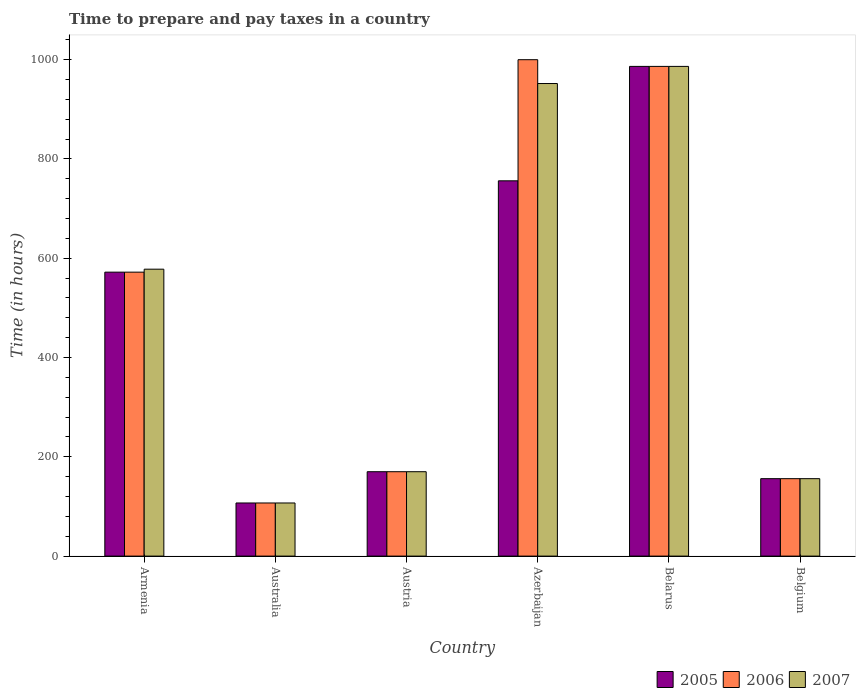How many groups of bars are there?
Give a very brief answer. 6. Are the number of bars per tick equal to the number of legend labels?
Provide a succinct answer. Yes. How many bars are there on the 4th tick from the left?
Offer a very short reply. 3. What is the label of the 2nd group of bars from the left?
Your response must be concise. Australia. In how many cases, is the number of bars for a given country not equal to the number of legend labels?
Keep it short and to the point. 0. What is the number of hours required to prepare and pay taxes in 2005 in Belarus?
Offer a very short reply. 986.5. Across all countries, what is the maximum number of hours required to prepare and pay taxes in 2006?
Your answer should be very brief. 1000. Across all countries, what is the minimum number of hours required to prepare and pay taxes in 2007?
Offer a terse response. 107. In which country was the number of hours required to prepare and pay taxes in 2005 maximum?
Your answer should be compact. Belarus. In which country was the number of hours required to prepare and pay taxes in 2006 minimum?
Offer a very short reply. Australia. What is the total number of hours required to prepare and pay taxes in 2007 in the graph?
Your answer should be compact. 2949.5. What is the difference between the number of hours required to prepare and pay taxes in 2007 in Austria and that in Azerbaijan?
Keep it short and to the point. -782. What is the difference between the number of hours required to prepare and pay taxes in 2005 in Azerbaijan and the number of hours required to prepare and pay taxes in 2006 in Austria?
Offer a very short reply. 586. What is the average number of hours required to prepare and pay taxes in 2005 per country?
Offer a very short reply. 457.92. In how many countries, is the number of hours required to prepare and pay taxes in 2006 greater than 520 hours?
Make the answer very short. 3. What is the ratio of the number of hours required to prepare and pay taxes in 2005 in Austria to that in Belarus?
Keep it short and to the point. 0.17. What is the difference between the highest and the second highest number of hours required to prepare and pay taxes in 2007?
Offer a terse response. -34.5. What is the difference between the highest and the lowest number of hours required to prepare and pay taxes in 2005?
Provide a succinct answer. 879.5. Is it the case that in every country, the sum of the number of hours required to prepare and pay taxes in 2007 and number of hours required to prepare and pay taxes in 2006 is greater than the number of hours required to prepare and pay taxes in 2005?
Ensure brevity in your answer.  Yes. How many bars are there?
Give a very brief answer. 18. How many countries are there in the graph?
Offer a terse response. 6. What is the difference between two consecutive major ticks on the Y-axis?
Offer a very short reply. 200. Where does the legend appear in the graph?
Offer a very short reply. Bottom right. How many legend labels are there?
Offer a terse response. 3. What is the title of the graph?
Your response must be concise. Time to prepare and pay taxes in a country. What is the label or title of the X-axis?
Offer a very short reply. Country. What is the label or title of the Y-axis?
Make the answer very short. Time (in hours). What is the Time (in hours) in 2005 in Armenia?
Offer a very short reply. 572. What is the Time (in hours) in 2006 in Armenia?
Keep it short and to the point. 572. What is the Time (in hours) of 2007 in Armenia?
Offer a terse response. 578. What is the Time (in hours) of 2005 in Australia?
Offer a terse response. 107. What is the Time (in hours) of 2006 in Australia?
Give a very brief answer. 107. What is the Time (in hours) in 2007 in Australia?
Keep it short and to the point. 107. What is the Time (in hours) of 2005 in Austria?
Ensure brevity in your answer.  170. What is the Time (in hours) in 2006 in Austria?
Offer a very short reply. 170. What is the Time (in hours) in 2007 in Austria?
Keep it short and to the point. 170. What is the Time (in hours) of 2005 in Azerbaijan?
Provide a short and direct response. 756. What is the Time (in hours) of 2007 in Azerbaijan?
Provide a short and direct response. 952. What is the Time (in hours) of 2005 in Belarus?
Make the answer very short. 986.5. What is the Time (in hours) of 2006 in Belarus?
Provide a succinct answer. 986.5. What is the Time (in hours) of 2007 in Belarus?
Keep it short and to the point. 986.5. What is the Time (in hours) of 2005 in Belgium?
Make the answer very short. 156. What is the Time (in hours) of 2006 in Belgium?
Ensure brevity in your answer.  156. What is the Time (in hours) in 2007 in Belgium?
Give a very brief answer. 156. Across all countries, what is the maximum Time (in hours) of 2005?
Provide a short and direct response. 986.5. Across all countries, what is the maximum Time (in hours) of 2007?
Your answer should be very brief. 986.5. Across all countries, what is the minimum Time (in hours) in 2005?
Your answer should be compact. 107. Across all countries, what is the minimum Time (in hours) in 2006?
Ensure brevity in your answer.  107. Across all countries, what is the minimum Time (in hours) of 2007?
Your response must be concise. 107. What is the total Time (in hours) in 2005 in the graph?
Make the answer very short. 2747.5. What is the total Time (in hours) of 2006 in the graph?
Your response must be concise. 2991.5. What is the total Time (in hours) in 2007 in the graph?
Your answer should be very brief. 2949.5. What is the difference between the Time (in hours) of 2005 in Armenia and that in Australia?
Your answer should be very brief. 465. What is the difference between the Time (in hours) of 2006 in Armenia and that in Australia?
Your response must be concise. 465. What is the difference between the Time (in hours) in 2007 in Armenia and that in Australia?
Offer a terse response. 471. What is the difference between the Time (in hours) of 2005 in Armenia and that in Austria?
Offer a terse response. 402. What is the difference between the Time (in hours) in 2006 in Armenia and that in Austria?
Make the answer very short. 402. What is the difference between the Time (in hours) in 2007 in Armenia and that in Austria?
Your answer should be very brief. 408. What is the difference between the Time (in hours) in 2005 in Armenia and that in Azerbaijan?
Your response must be concise. -184. What is the difference between the Time (in hours) of 2006 in Armenia and that in Azerbaijan?
Provide a succinct answer. -428. What is the difference between the Time (in hours) of 2007 in Armenia and that in Azerbaijan?
Give a very brief answer. -374. What is the difference between the Time (in hours) in 2005 in Armenia and that in Belarus?
Ensure brevity in your answer.  -414.5. What is the difference between the Time (in hours) in 2006 in Armenia and that in Belarus?
Your answer should be compact. -414.5. What is the difference between the Time (in hours) in 2007 in Armenia and that in Belarus?
Offer a very short reply. -408.5. What is the difference between the Time (in hours) in 2005 in Armenia and that in Belgium?
Keep it short and to the point. 416. What is the difference between the Time (in hours) of 2006 in Armenia and that in Belgium?
Offer a terse response. 416. What is the difference between the Time (in hours) in 2007 in Armenia and that in Belgium?
Offer a very short reply. 422. What is the difference between the Time (in hours) in 2005 in Australia and that in Austria?
Provide a succinct answer. -63. What is the difference between the Time (in hours) in 2006 in Australia and that in Austria?
Ensure brevity in your answer.  -63. What is the difference between the Time (in hours) in 2007 in Australia and that in Austria?
Make the answer very short. -63. What is the difference between the Time (in hours) of 2005 in Australia and that in Azerbaijan?
Provide a short and direct response. -649. What is the difference between the Time (in hours) of 2006 in Australia and that in Azerbaijan?
Offer a very short reply. -893. What is the difference between the Time (in hours) in 2007 in Australia and that in Azerbaijan?
Offer a terse response. -845. What is the difference between the Time (in hours) in 2005 in Australia and that in Belarus?
Ensure brevity in your answer.  -879.5. What is the difference between the Time (in hours) in 2006 in Australia and that in Belarus?
Your answer should be compact. -879.5. What is the difference between the Time (in hours) of 2007 in Australia and that in Belarus?
Your response must be concise. -879.5. What is the difference between the Time (in hours) of 2005 in Australia and that in Belgium?
Provide a succinct answer. -49. What is the difference between the Time (in hours) of 2006 in Australia and that in Belgium?
Offer a very short reply. -49. What is the difference between the Time (in hours) of 2007 in Australia and that in Belgium?
Offer a very short reply. -49. What is the difference between the Time (in hours) of 2005 in Austria and that in Azerbaijan?
Your answer should be compact. -586. What is the difference between the Time (in hours) in 2006 in Austria and that in Azerbaijan?
Ensure brevity in your answer.  -830. What is the difference between the Time (in hours) of 2007 in Austria and that in Azerbaijan?
Provide a succinct answer. -782. What is the difference between the Time (in hours) of 2005 in Austria and that in Belarus?
Make the answer very short. -816.5. What is the difference between the Time (in hours) of 2006 in Austria and that in Belarus?
Offer a very short reply. -816.5. What is the difference between the Time (in hours) of 2007 in Austria and that in Belarus?
Your answer should be compact. -816.5. What is the difference between the Time (in hours) of 2005 in Austria and that in Belgium?
Ensure brevity in your answer.  14. What is the difference between the Time (in hours) in 2005 in Azerbaijan and that in Belarus?
Your answer should be very brief. -230.5. What is the difference between the Time (in hours) of 2007 in Azerbaijan and that in Belarus?
Provide a succinct answer. -34.5. What is the difference between the Time (in hours) of 2005 in Azerbaijan and that in Belgium?
Your answer should be very brief. 600. What is the difference between the Time (in hours) of 2006 in Azerbaijan and that in Belgium?
Provide a succinct answer. 844. What is the difference between the Time (in hours) in 2007 in Azerbaijan and that in Belgium?
Your answer should be compact. 796. What is the difference between the Time (in hours) in 2005 in Belarus and that in Belgium?
Give a very brief answer. 830.5. What is the difference between the Time (in hours) in 2006 in Belarus and that in Belgium?
Your response must be concise. 830.5. What is the difference between the Time (in hours) of 2007 in Belarus and that in Belgium?
Your answer should be very brief. 830.5. What is the difference between the Time (in hours) in 2005 in Armenia and the Time (in hours) in 2006 in Australia?
Your answer should be compact. 465. What is the difference between the Time (in hours) in 2005 in Armenia and the Time (in hours) in 2007 in Australia?
Offer a very short reply. 465. What is the difference between the Time (in hours) in 2006 in Armenia and the Time (in hours) in 2007 in Australia?
Make the answer very short. 465. What is the difference between the Time (in hours) in 2005 in Armenia and the Time (in hours) in 2006 in Austria?
Make the answer very short. 402. What is the difference between the Time (in hours) in 2005 in Armenia and the Time (in hours) in 2007 in Austria?
Keep it short and to the point. 402. What is the difference between the Time (in hours) in 2006 in Armenia and the Time (in hours) in 2007 in Austria?
Your response must be concise. 402. What is the difference between the Time (in hours) in 2005 in Armenia and the Time (in hours) in 2006 in Azerbaijan?
Your answer should be very brief. -428. What is the difference between the Time (in hours) in 2005 in Armenia and the Time (in hours) in 2007 in Azerbaijan?
Offer a terse response. -380. What is the difference between the Time (in hours) in 2006 in Armenia and the Time (in hours) in 2007 in Azerbaijan?
Your answer should be compact. -380. What is the difference between the Time (in hours) in 2005 in Armenia and the Time (in hours) in 2006 in Belarus?
Your response must be concise. -414.5. What is the difference between the Time (in hours) of 2005 in Armenia and the Time (in hours) of 2007 in Belarus?
Your response must be concise. -414.5. What is the difference between the Time (in hours) of 2006 in Armenia and the Time (in hours) of 2007 in Belarus?
Your response must be concise. -414.5. What is the difference between the Time (in hours) of 2005 in Armenia and the Time (in hours) of 2006 in Belgium?
Your response must be concise. 416. What is the difference between the Time (in hours) of 2005 in Armenia and the Time (in hours) of 2007 in Belgium?
Offer a terse response. 416. What is the difference between the Time (in hours) in 2006 in Armenia and the Time (in hours) in 2007 in Belgium?
Your response must be concise. 416. What is the difference between the Time (in hours) of 2005 in Australia and the Time (in hours) of 2006 in Austria?
Give a very brief answer. -63. What is the difference between the Time (in hours) in 2005 in Australia and the Time (in hours) in 2007 in Austria?
Offer a very short reply. -63. What is the difference between the Time (in hours) in 2006 in Australia and the Time (in hours) in 2007 in Austria?
Offer a terse response. -63. What is the difference between the Time (in hours) in 2005 in Australia and the Time (in hours) in 2006 in Azerbaijan?
Your response must be concise. -893. What is the difference between the Time (in hours) in 2005 in Australia and the Time (in hours) in 2007 in Azerbaijan?
Your response must be concise. -845. What is the difference between the Time (in hours) of 2006 in Australia and the Time (in hours) of 2007 in Azerbaijan?
Your response must be concise. -845. What is the difference between the Time (in hours) in 2005 in Australia and the Time (in hours) in 2006 in Belarus?
Give a very brief answer. -879.5. What is the difference between the Time (in hours) of 2005 in Australia and the Time (in hours) of 2007 in Belarus?
Your answer should be compact. -879.5. What is the difference between the Time (in hours) in 2006 in Australia and the Time (in hours) in 2007 in Belarus?
Offer a very short reply. -879.5. What is the difference between the Time (in hours) in 2005 in Australia and the Time (in hours) in 2006 in Belgium?
Keep it short and to the point. -49. What is the difference between the Time (in hours) in 2005 in Australia and the Time (in hours) in 2007 in Belgium?
Ensure brevity in your answer.  -49. What is the difference between the Time (in hours) in 2006 in Australia and the Time (in hours) in 2007 in Belgium?
Offer a very short reply. -49. What is the difference between the Time (in hours) of 2005 in Austria and the Time (in hours) of 2006 in Azerbaijan?
Provide a short and direct response. -830. What is the difference between the Time (in hours) of 2005 in Austria and the Time (in hours) of 2007 in Azerbaijan?
Keep it short and to the point. -782. What is the difference between the Time (in hours) of 2006 in Austria and the Time (in hours) of 2007 in Azerbaijan?
Your answer should be compact. -782. What is the difference between the Time (in hours) in 2005 in Austria and the Time (in hours) in 2006 in Belarus?
Offer a very short reply. -816.5. What is the difference between the Time (in hours) of 2005 in Austria and the Time (in hours) of 2007 in Belarus?
Provide a short and direct response. -816.5. What is the difference between the Time (in hours) of 2006 in Austria and the Time (in hours) of 2007 in Belarus?
Ensure brevity in your answer.  -816.5. What is the difference between the Time (in hours) in 2006 in Austria and the Time (in hours) in 2007 in Belgium?
Provide a short and direct response. 14. What is the difference between the Time (in hours) in 2005 in Azerbaijan and the Time (in hours) in 2006 in Belarus?
Make the answer very short. -230.5. What is the difference between the Time (in hours) in 2005 in Azerbaijan and the Time (in hours) in 2007 in Belarus?
Your answer should be very brief. -230.5. What is the difference between the Time (in hours) in 2006 in Azerbaijan and the Time (in hours) in 2007 in Belarus?
Keep it short and to the point. 13.5. What is the difference between the Time (in hours) in 2005 in Azerbaijan and the Time (in hours) in 2006 in Belgium?
Provide a succinct answer. 600. What is the difference between the Time (in hours) in 2005 in Azerbaijan and the Time (in hours) in 2007 in Belgium?
Provide a succinct answer. 600. What is the difference between the Time (in hours) of 2006 in Azerbaijan and the Time (in hours) of 2007 in Belgium?
Offer a very short reply. 844. What is the difference between the Time (in hours) in 2005 in Belarus and the Time (in hours) in 2006 in Belgium?
Provide a succinct answer. 830.5. What is the difference between the Time (in hours) of 2005 in Belarus and the Time (in hours) of 2007 in Belgium?
Ensure brevity in your answer.  830.5. What is the difference between the Time (in hours) in 2006 in Belarus and the Time (in hours) in 2007 in Belgium?
Your answer should be very brief. 830.5. What is the average Time (in hours) in 2005 per country?
Offer a very short reply. 457.92. What is the average Time (in hours) in 2006 per country?
Make the answer very short. 498.58. What is the average Time (in hours) in 2007 per country?
Ensure brevity in your answer.  491.58. What is the difference between the Time (in hours) of 2005 and Time (in hours) of 2006 in Armenia?
Keep it short and to the point. 0. What is the difference between the Time (in hours) in 2005 and Time (in hours) in 2007 in Australia?
Your answer should be compact. 0. What is the difference between the Time (in hours) of 2006 and Time (in hours) of 2007 in Australia?
Offer a terse response. 0. What is the difference between the Time (in hours) of 2005 and Time (in hours) of 2007 in Austria?
Provide a succinct answer. 0. What is the difference between the Time (in hours) in 2006 and Time (in hours) in 2007 in Austria?
Provide a succinct answer. 0. What is the difference between the Time (in hours) in 2005 and Time (in hours) in 2006 in Azerbaijan?
Keep it short and to the point. -244. What is the difference between the Time (in hours) in 2005 and Time (in hours) in 2007 in Azerbaijan?
Your answer should be compact. -196. What is the difference between the Time (in hours) in 2006 and Time (in hours) in 2007 in Azerbaijan?
Your answer should be compact. 48. What is the difference between the Time (in hours) in 2005 and Time (in hours) in 2006 in Belarus?
Your answer should be very brief. 0. What is the difference between the Time (in hours) of 2006 and Time (in hours) of 2007 in Belarus?
Your answer should be very brief. 0. What is the difference between the Time (in hours) of 2006 and Time (in hours) of 2007 in Belgium?
Your answer should be very brief. 0. What is the ratio of the Time (in hours) of 2005 in Armenia to that in Australia?
Ensure brevity in your answer.  5.35. What is the ratio of the Time (in hours) in 2006 in Armenia to that in Australia?
Make the answer very short. 5.35. What is the ratio of the Time (in hours) of 2007 in Armenia to that in Australia?
Keep it short and to the point. 5.4. What is the ratio of the Time (in hours) in 2005 in Armenia to that in Austria?
Offer a terse response. 3.36. What is the ratio of the Time (in hours) in 2006 in Armenia to that in Austria?
Offer a terse response. 3.36. What is the ratio of the Time (in hours) of 2007 in Armenia to that in Austria?
Your answer should be compact. 3.4. What is the ratio of the Time (in hours) of 2005 in Armenia to that in Azerbaijan?
Your response must be concise. 0.76. What is the ratio of the Time (in hours) of 2006 in Armenia to that in Azerbaijan?
Your response must be concise. 0.57. What is the ratio of the Time (in hours) of 2007 in Armenia to that in Azerbaijan?
Provide a short and direct response. 0.61. What is the ratio of the Time (in hours) in 2005 in Armenia to that in Belarus?
Offer a very short reply. 0.58. What is the ratio of the Time (in hours) in 2006 in Armenia to that in Belarus?
Provide a short and direct response. 0.58. What is the ratio of the Time (in hours) of 2007 in Armenia to that in Belarus?
Offer a terse response. 0.59. What is the ratio of the Time (in hours) of 2005 in Armenia to that in Belgium?
Your answer should be very brief. 3.67. What is the ratio of the Time (in hours) in 2006 in Armenia to that in Belgium?
Your answer should be very brief. 3.67. What is the ratio of the Time (in hours) of 2007 in Armenia to that in Belgium?
Your answer should be compact. 3.71. What is the ratio of the Time (in hours) in 2005 in Australia to that in Austria?
Give a very brief answer. 0.63. What is the ratio of the Time (in hours) in 2006 in Australia to that in Austria?
Offer a very short reply. 0.63. What is the ratio of the Time (in hours) in 2007 in Australia to that in Austria?
Keep it short and to the point. 0.63. What is the ratio of the Time (in hours) in 2005 in Australia to that in Azerbaijan?
Give a very brief answer. 0.14. What is the ratio of the Time (in hours) in 2006 in Australia to that in Azerbaijan?
Provide a short and direct response. 0.11. What is the ratio of the Time (in hours) in 2007 in Australia to that in Azerbaijan?
Offer a terse response. 0.11. What is the ratio of the Time (in hours) in 2005 in Australia to that in Belarus?
Offer a very short reply. 0.11. What is the ratio of the Time (in hours) of 2006 in Australia to that in Belarus?
Keep it short and to the point. 0.11. What is the ratio of the Time (in hours) of 2007 in Australia to that in Belarus?
Make the answer very short. 0.11. What is the ratio of the Time (in hours) in 2005 in Australia to that in Belgium?
Make the answer very short. 0.69. What is the ratio of the Time (in hours) in 2006 in Australia to that in Belgium?
Ensure brevity in your answer.  0.69. What is the ratio of the Time (in hours) of 2007 in Australia to that in Belgium?
Your response must be concise. 0.69. What is the ratio of the Time (in hours) of 2005 in Austria to that in Azerbaijan?
Your answer should be very brief. 0.22. What is the ratio of the Time (in hours) of 2006 in Austria to that in Azerbaijan?
Make the answer very short. 0.17. What is the ratio of the Time (in hours) of 2007 in Austria to that in Azerbaijan?
Provide a short and direct response. 0.18. What is the ratio of the Time (in hours) of 2005 in Austria to that in Belarus?
Provide a succinct answer. 0.17. What is the ratio of the Time (in hours) in 2006 in Austria to that in Belarus?
Provide a succinct answer. 0.17. What is the ratio of the Time (in hours) in 2007 in Austria to that in Belarus?
Provide a short and direct response. 0.17. What is the ratio of the Time (in hours) of 2005 in Austria to that in Belgium?
Provide a succinct answer. 1.09. What is the ratio of the Time (in hours) of 2006 in Austria to that in Belgium?
Provide a succinct answer. 1.09. What is the ratio of the Time (in hours) in 2007 in Austria to that in Belgium?
Your answer should be very brief. 1.09. What is the ratio of the Time (in hours) in 2005 in Azerbaijan to that in Belarus?
Keep it short and to the point. 0.77. What is the ratio of the Time (in hours) in 2006 in Azerbaijan to that in Belarus?
Provide a short and direct response. 1.01. What is the ratio of the Time (in hours) of 2007 in Azerbaijan to that in Belarus?
Your answer should be compact. 0.96. What is the ratio of the Time (in hours) of 2005 in Azerbaijan to that in Belgium?
Provide a succinct answer. 4.85. What is the ratio of the Time (in hours) of 2006 in Azerbaijan to that in Belgium?
Ensure brevity in your answer.  6.41. What is the ratio of the Time (in hours) in 2007 in Azerbaijan to that in Belgium?
Ensure brevity in your answer.  6.1. What is the ratio of the Time (in hours) of 2005 in Belarus to that in Belgium?
Give a very brief answer. 6.32. What is the ratio of the Time (in hours) of 2006 in Belarus to that in Belgium?
Offer a terse response. 6.32. What is the ratio of the Time (in hours) of 2007 in Belarus to that in Belgium?
Give a very brief answer. 6.32. What is the difference between the highest and the second highest Time (in hours) of 2005?
Provide a short and direct response. 230.5. What is the difference between the highest and the second highest Time (in hours) of 2007?
Your answer should be compact. 34.5. What is the difference between the highest and the lowest Time (in hours) of 2005?
Your answer should be compact. 879.5. What is the difference between the highest and the lowest Time (in hours) of 2006?
Ensure brevity in your answer.  893. What is the difference between the highest and the lowest Time (in hours) of 2007?
Provide a short and direct response. 879.5. 